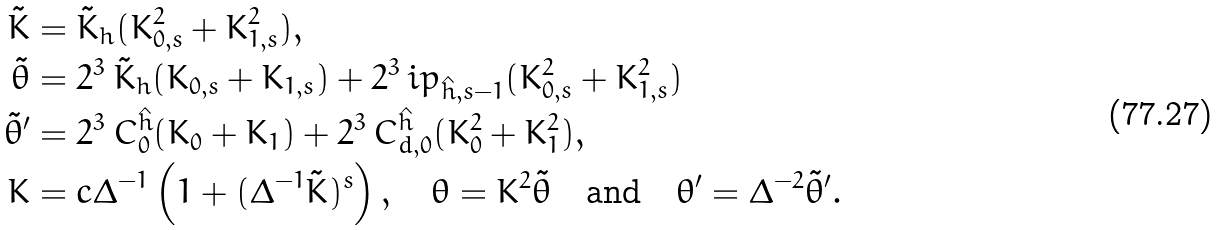Convert formula to latex. <formula><loc_0><loc_0><loc_500><loc_500>\tilde { K } & = \tilde { K } _ { h } ( K _ { 0 , s } ^ { 2 } + K _ { 1 , s } ^ { 2 } ) , \\ \tilde { \theta } & = 2 ^ { 3 } \, \tilde { K } _ { h } ( K _ { 0 , s } + K _ { 1 , s } ) + 2 ^ { 3 } \, \L i p _ { \hat { h } , s - 1 } ( K _ { 0 , s } ^ { 2 } + K _ { 1 , s } ^ { 2 } ) \\ \tilde { \theta } ^ { \prime } & = 2 ^ { 3 } \, C ^ { \hat { h } } _ { 0 } ( K _ { 0 } + K _ { 1 } ) + 2 ^ { 3 } \, C ^ { \hat { h } } _ { d , 0 } ( K _ { 0 } ^ { 2 } + K _ { 1 } ^ { 2 } ) , \\ K & = c \Delta ^ { - 1 } \left ( 1 + ( \Delta ^ { - 1 } \tilde { K } ) ^ { s } \right ) , \quad \theta = K ^ { 2 } \tilde { \theta } \quad \text {and} \quad \theta ^ { \prime } = \Delta ^ { - 2 } \tilde { \theta } ^ { \prime } .</formula> 